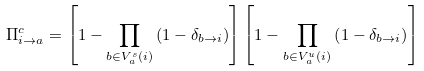Convert formula to latex. <formula><loc_0><loc_0><loc_500><loc_500>\Pi ^ { c } _ { i \to a } = \left [ 1 - \prod _ { b \in V ^ { s } _ { a } ( i ) } \left ( 1 - \delta _ { b \to i } \right ) \right ] \left [ 1 - \prod _ { b \in V ^ { u } _ { a } ( i ) } \left ( 1 - \delta _ { b \to i } \right ) \right ]</formula> 